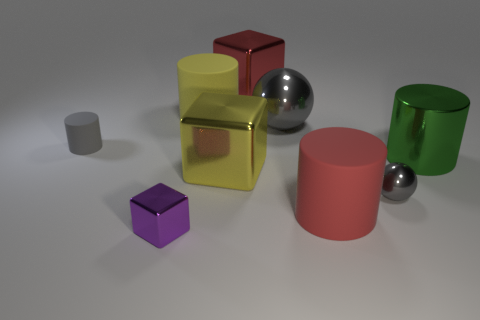Add 1 green cylinders. How many objects exist? 10 Subtract all brown cylinders. Subtract all cyan balls. How many cylinders are left? 4 Subtract all balls. How many objects are left? 7 Add 9 large yellow metallic things. How many large yellow metallic things are left? 10 Add 9 big yellow matte cylinders. How many big yellow matte cylinders exist? 10 Subtract 0 blue cylinders. How many objects are left? 9 Subtract all yellow rubber cylinders. Subtract all large matte cylinders. How many objects are left? 6 